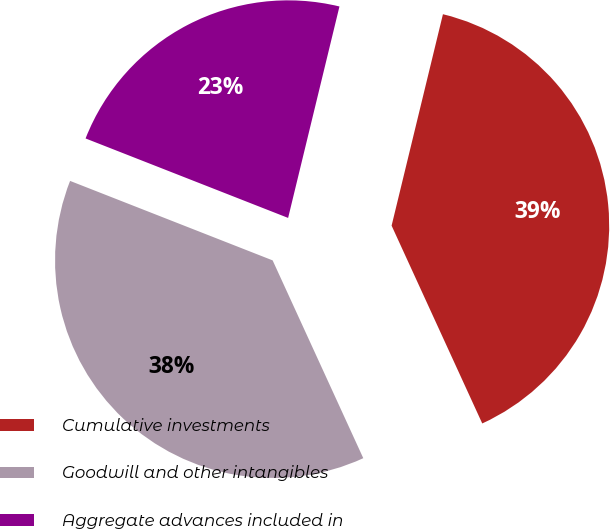Convert chart to OTSL. <chart><loc_0><loc_0><loc_500><loc_500><pie_chart><fcel>Cumulative investments<fcel>Goodwill and other intangibles<fcel>Aggregate advances included in<nl><fcel>39.37%<fcel>37.79%<fcel>22.84%<nl></chart> 